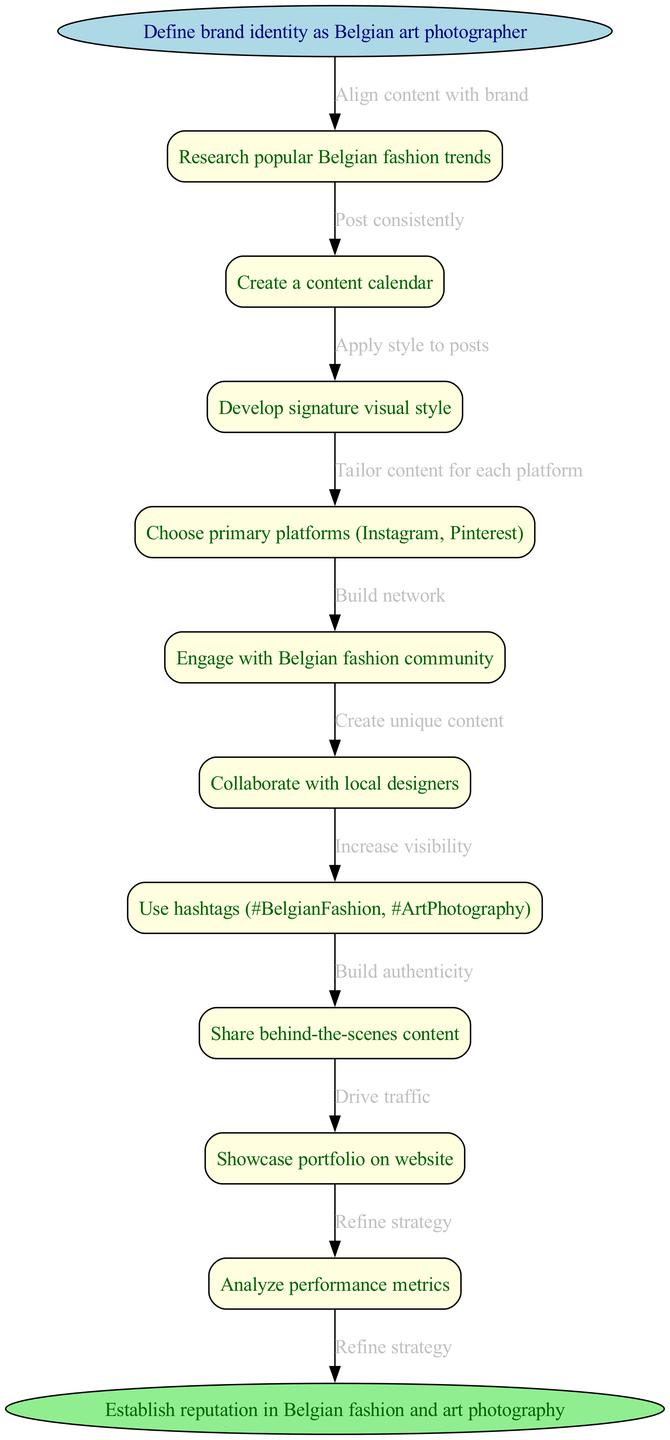What is the starting node of the flowchart? The starting node is labeled "Define brand identity as Belgian art photographer," which is the first step shown in the diagram.
Answer: Define brand identity as Belgian art photographer How many nodes are in the diagram? Counting all the nodes including the start and end nodes, there are a total of 12 nodes.
Answer: 12 What is the last node before reaching the end node? The last node before the end node is "Analyze performance metrics," which is the final step before establishing the reputation in the field.
Answer: Analyze performance metrics What is the primary goal of the flowchart? The primary goal is indicated by the end node, which is "Establish reputation in Belgian fashion and art photography."
Answer: Establish reputation in Belgian fashion and art photography Which node focuses on building relationships in the community? The node that focuses on building relationships is "Engage with Belgian fashion community," where the photographer aims to network within the industry.
Answer: Engage with Belgian fashion community How many edges connect the first node to subsequent nodes? There is one edge connecting the starting node to its first node, which indicates a direct line of progression in the strategy.
Answer: 1 What is the relationship between "Create a content calendar" and "Post consistently"? The edge between these two nodes indicates that creating a content calendar directly supports the strategy of posting consistently to keep the audience engaged.
Answer: Post consistently Which node involves a visual aspect related to photography? The node "Develop signature visual style" emphasizes the unique visual creativity involved in fashion photography, focusing on aesthetic consistency.
Answer: Develop signature visual style What does the edge between "Use hashtags" and "Increase visibility" signify? This edge signifies that employing specific hashtags like #BelgianFashion directly contributes to enhancing the visibility of the photographer's work on social media platforms.
Answer: Increase visibility 